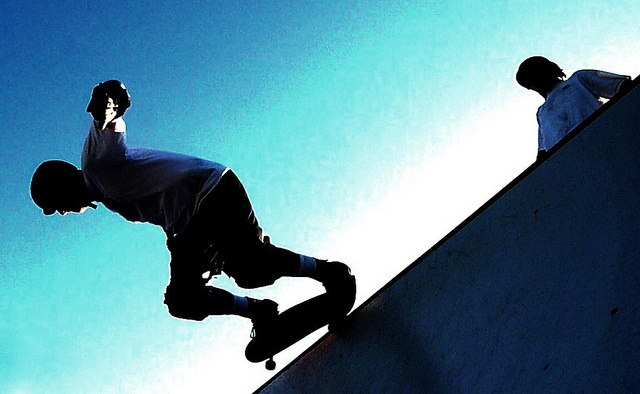Describe the objects in this image and their specific colors. I can see people in blue, black, white, and navy tones, people in blue, black, navy, and darkblue tones, and skateboard in blue, black, white, gray, and darkgray tones in this image. 